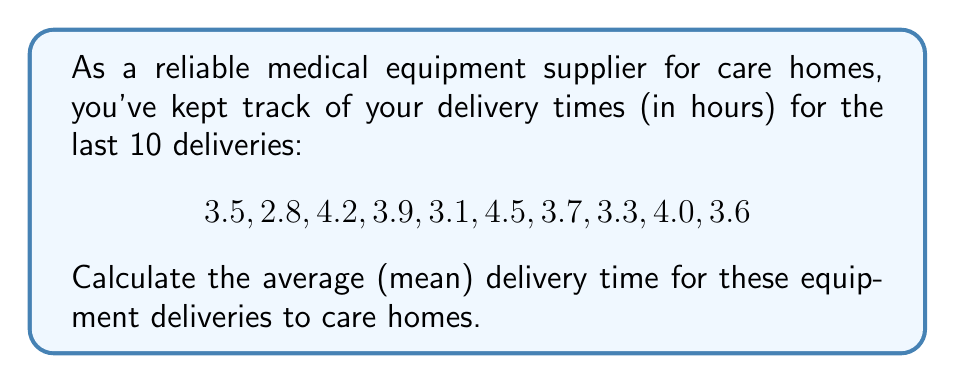Teach me how to tackle this problem. To calculate the average (mean) delivery time, we need to follow these steps:

1. Sum up all the delivery times:
   $$ \sum_{i=1}^{10} x_i = 3.5 + 2.8 + 4.2 + 3.9 + 3.1 + 4.5 + 3.7 + 3.3 + 4.0 + 3.6 = 36.6 \text{ hours} $$

2. Count the total number of deliveries:
   $$ n = 10 $$

3. Apply the formula for arithmetic mean:
   $$ \bar{x} = \frac{\sum_{i=1}^{n} x_i}{n} $$

4. Substitute the values:
   $$ \bar{x} = \frac{36.6}{10} = 3.66 \text{ hours} $$

Therefore, the average delivery time is 3.66 hours.
Answer: The average (mean) delivery time is 3.66 hours. 